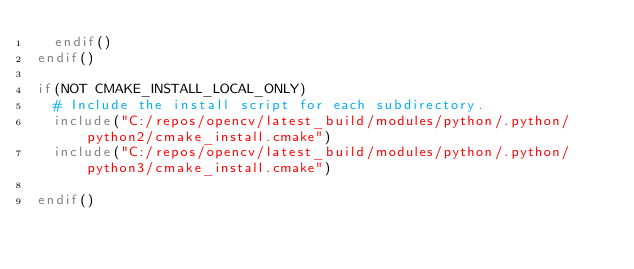<code> <loc_0><loc_0><loc_500><loc_500><_CMake_>  endif()
endif()

if(NOT CMAKE_INSTALL_LOCAL_ONLY)
  # Include the install script for each subdirectory.
  include("C:/repos/opencv/latest_build/modules/python/.python/python2/cmake_install.cmake")
  include("C:/repos/opencv/latest_build/modules/python/.python/python3/cmake_install.cmake")

endif()

</code> 